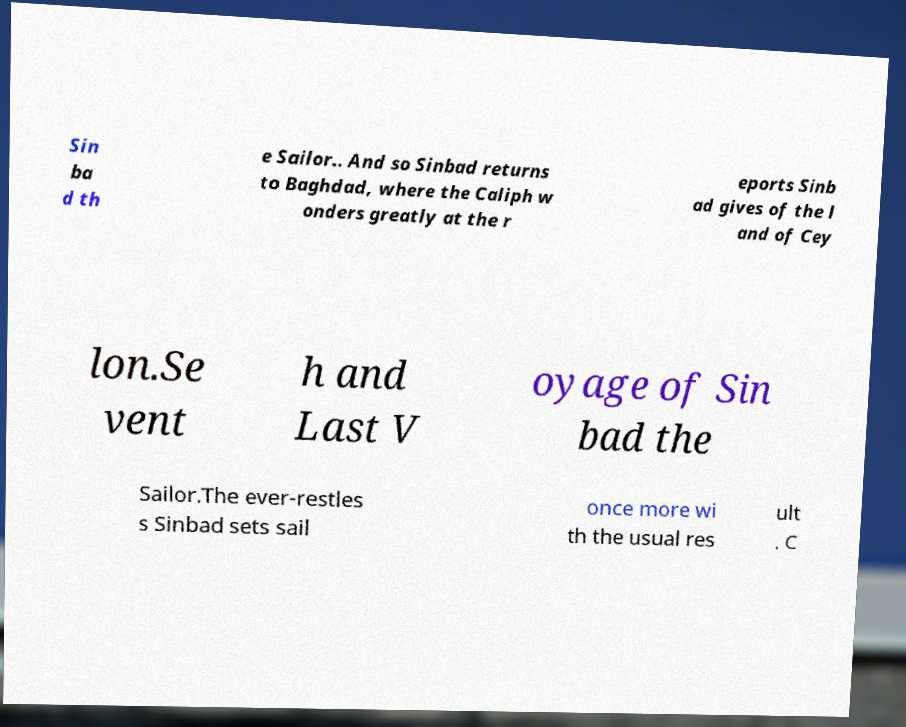What messages or text are displayed in this image? I need them in a readable, typed format. Sin ba d th e Sailor.. And so Sinbad returns to Baghdad, where the Caliph w onders greatly at the r eports Sinb ad gives of the l and of Cey lon.Se vent h and Last V oyage of Sin bad the Sailor.The ever-restles s Sinbad sets sail once more wi th the usual res ult . C 